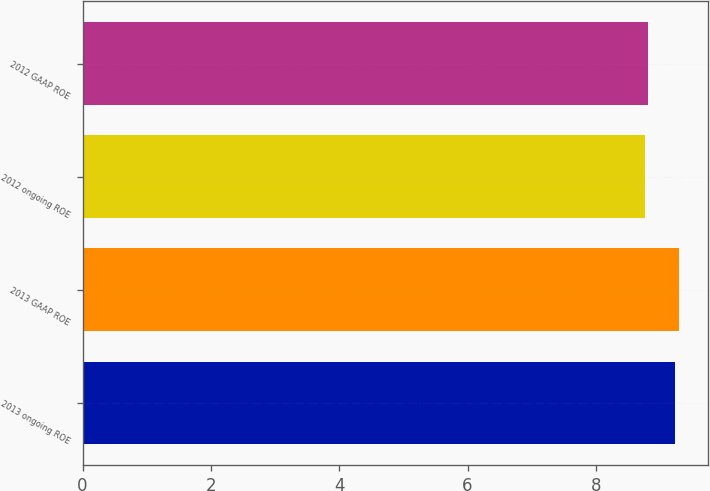Convert chart. <chart><loc_0><loc_0><loc_500><loc_500><bar_chart><fcel>2013 ongoing ROE<fcel>2013 GAAP ROE<fcel>2012 ongoing ROE<fcel>2012 GAAP ROE<nl><fcel>9.24<fcel>9.29<fcel>8.77<fcel>8.82<nl></chart> 